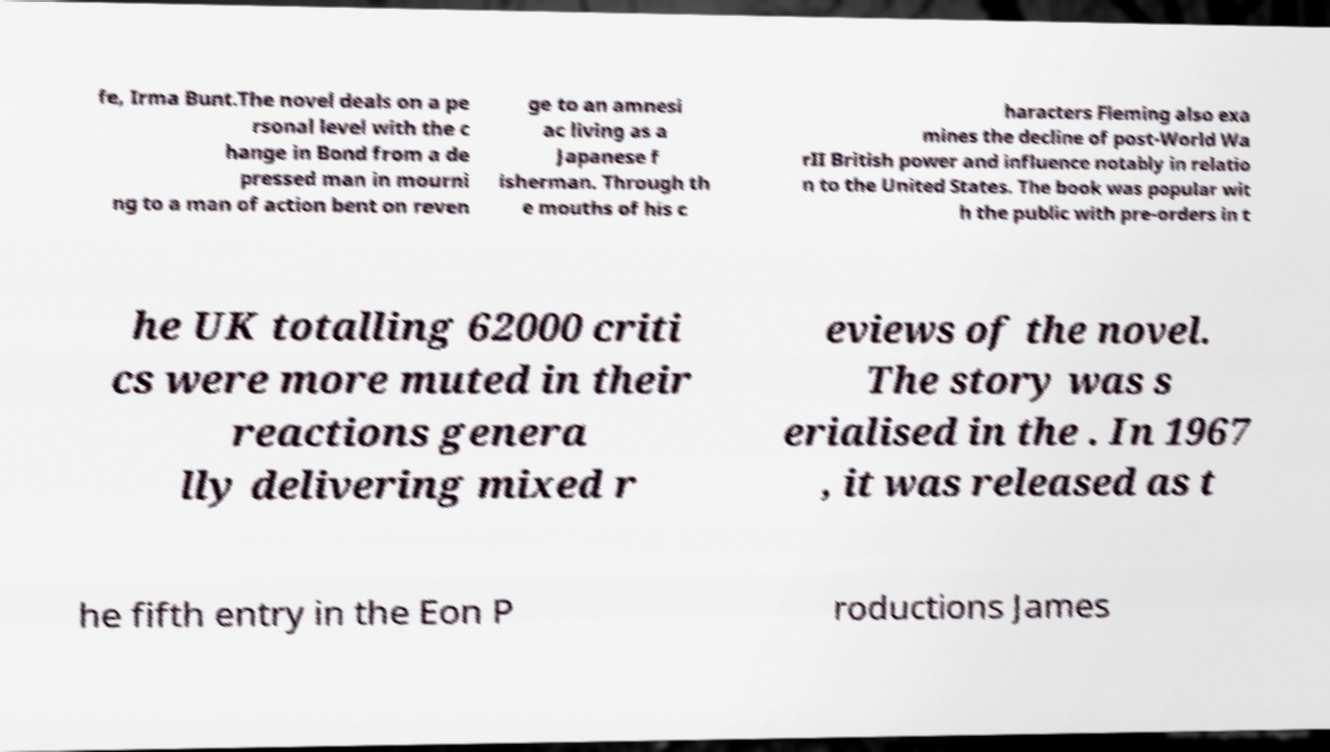For documentation purposes, I need the text within this image transcribed. Could you provide that? fe, Irma Bunt.The novel deals on a pe rsonal level with the c hange in Bond from a de pressed man in mourni ng to a man of action bent on reven ge to an amnesi ac living as a Japanese f isherman. Through th e mouths of his c haracters Fleming also exa mines the decline of post-World Wa rII British power and influence notably in relatio n to the United States. The book was popular wit h the public with pre-orders in t he UK totalling 62000 criti cs were more muted in their reactions genera lly delivering mixed r eviews of the novel. The story was s erialised in the . In 1967 , it was released as t he fifth entry in the Eon P roductions James 